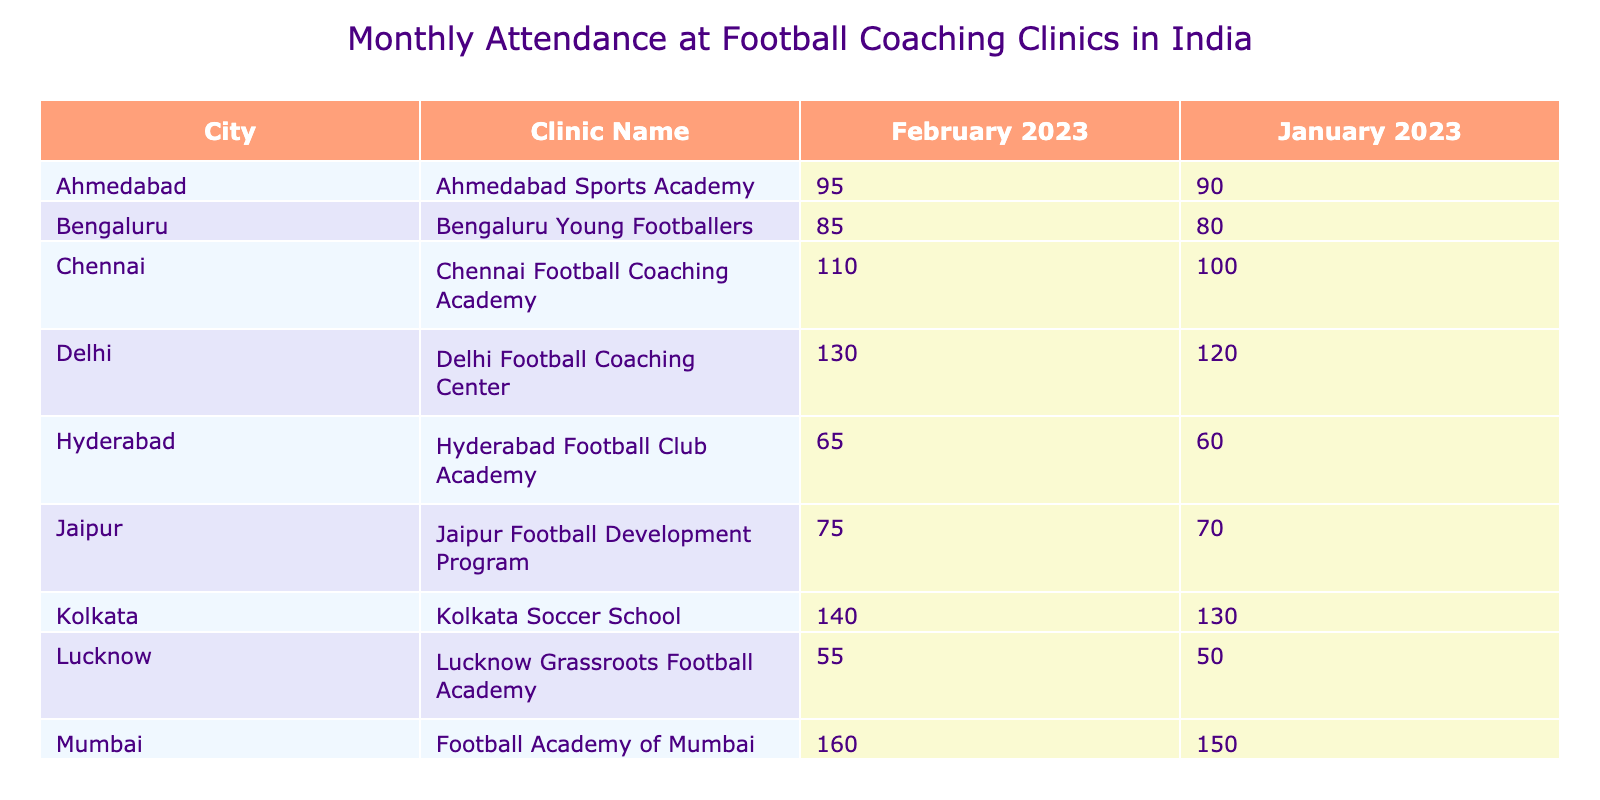What city hosts the clinic with the highest attendance in January 2023? The clinics' attendance in January 2023 shows Mumbai's Football Academy of Mumbai with 150 attendees, which is the highest among all cities listed for that month.
Answer: Mumbai How many attendees were there at the Delhi Football Coaching Center in February 2023? Referring to the table, the number of attendees at the Delhi Football Coaching Center in February 2023 is listed as 130.
Answer: 130 What is the total attendance for all clinics in Mumbai for January and February 2023? The total attendance for Mumbai's clinics is 150 (January) + 160 (February) = 310.
Answer: 310 Is the number of attendees at the Kolkata Soccer School in January 2023 greater than that at the Bengaluru Young Footballers in the same month? Yes, because Kolkata Soccer School had 130 attendees, while Bengaluru Young Footballers had 80 attendees in January 2023.
Answer: Yes What is the average attendance at Chennai Football Coaching Academy for January and February 2023? The attendance for Chennai Football Coaching Academy in January is 100 and in February is 110. The average is (100 + 110) / 2 = 105.
Answer: 105 Which clinic had the lowest attendance in February 2023? The Lucknow Grassroots Football Academy has the lowest attendance in February 2023 with 55 attendees, the least when compared to other clinics for that month.
Answer: Lucknow Grassroots Football Academy Which city has the most clinics listed in the table? The table shows one clinic for each city listed, thus no city has more than one clinic in this table.
Answer: No city has more than one clinic What is the difference in attendance between the highest and lowest-attended clinic in January 2023? The highest-attended clinic is Mumbai's Football Academy with 150 attendees, and the lowest is Lucknow's Grassroots Football Academy with 50 attendees. The difference is 150 - 50 = 100.
Answer: 100 What percentage of attendees in Hyderabad in February attended at the Hyderabad Football Club Academy compared to the total of all clinics? The attendance for Hyderabad in February is 65. The total number of attendees for February across all clinics is 1,150 (sum of all entries). The percentage is (65 / 1150) * 100 ≈ 5.65%.
Answer: 5.65% 